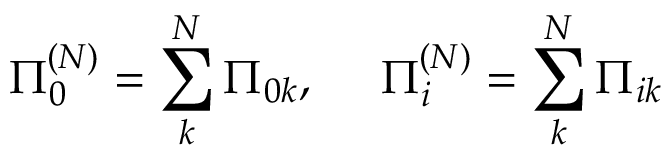Convert formula to latex. <formula><loc_0><loc_0><loc_500><loc_500>\Pi _ { 0 } ^ { ( N ) } = \sum _ { k } ^ { N } \Pi _ { 0 k } , \Pi _ { i } ^ { ( N ) } = \sum _ { k } ^ { N } \Pi _ { i k }</formula> 